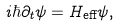<formula> <loc_0><loc_0><loc_500><loc_500>i \hbar { \partial } _ { t } \psi = H _ { \text {eff} } \psi ,</formula> 